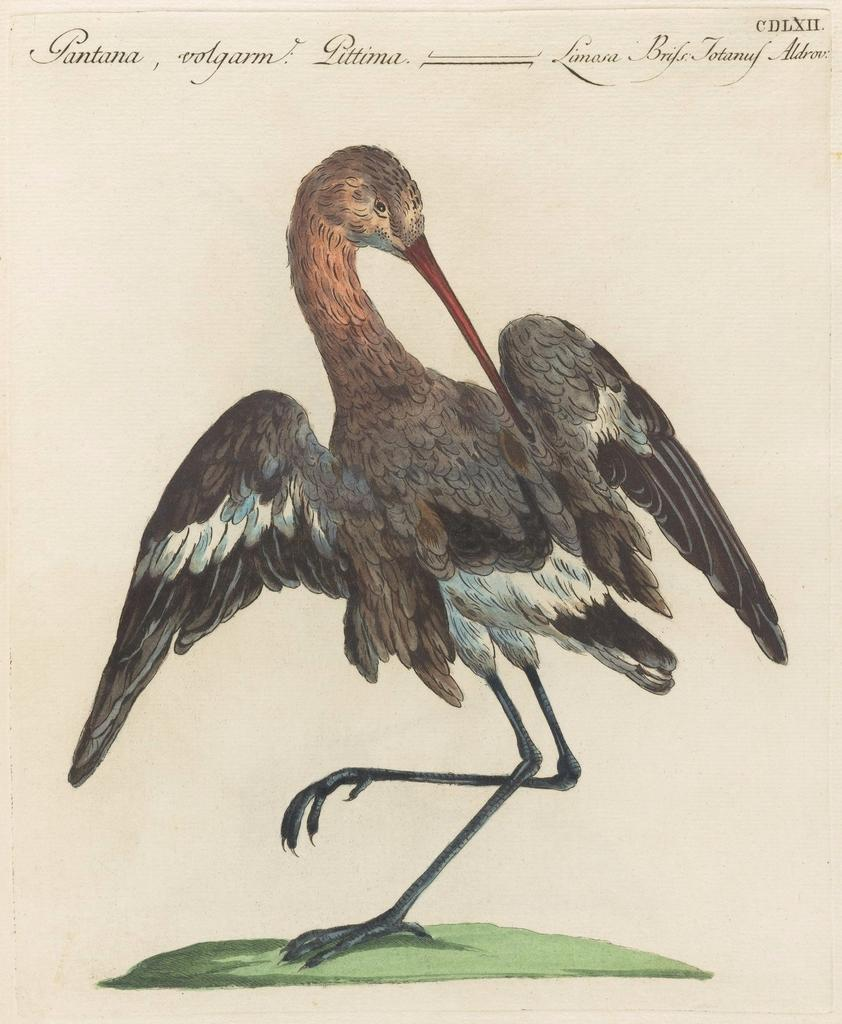What is shown on the paper in the image? There is a depiction of a bird on the paper. What type of vegetation is depicted at the bottom of the paper? There is grass depicted at the bottom of the paper. What is written or printed at the top of the paper? There is text present at the top of the paper. Is there a river flowing through the grass depicted on the paper? No, there is no river depicted on the paper; only grass is shown at the bottom. 